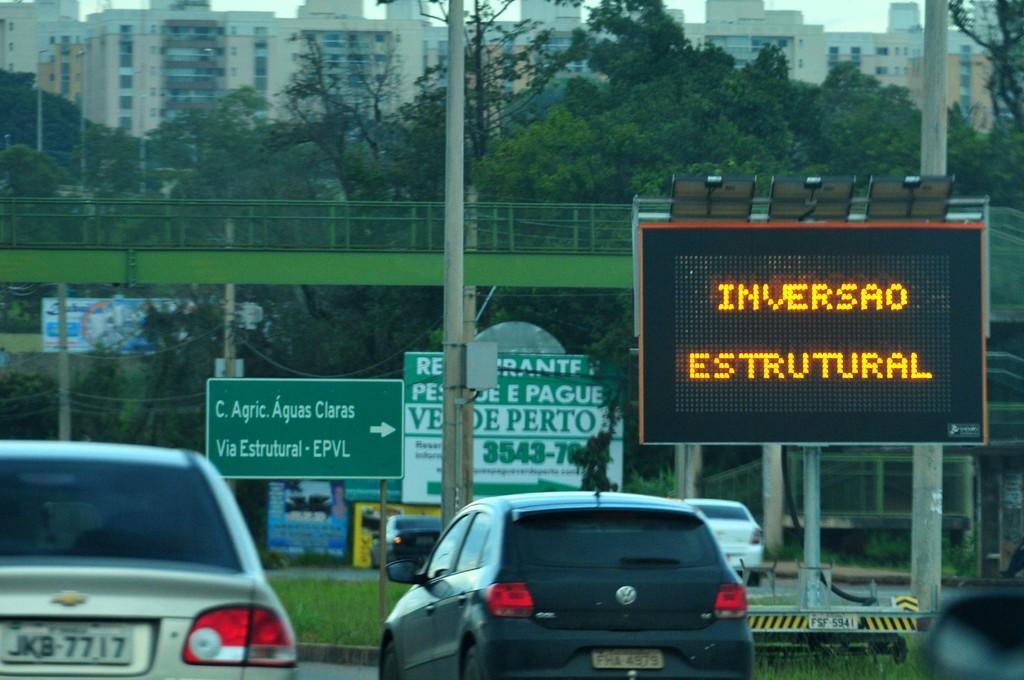In one or two sentences, can you explain what this image depicts? In this picture we can see some vehicles on the roads. In front of the vehicles there are boards, poles, grass and a bridge. Behind the bridge, there are trees, buildings and the sky. 